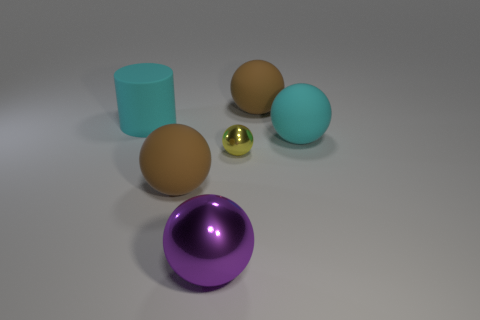Subtract all yellow balls. How many balls are left? 4 Subtract all large cyan matte spheres. How many spheres are left? 4 Subtract all cyan spheres. Subtract all yellow cylinders. How many spheres are left? 4 Add 3 big brown balls. How many objects exist? 9 Subtract 2 brown balls. How many objects are left? 4 Subtract all spheres. How many objects are left? 1 Subtract all large green shiny cubes. Subtract all small yellow balls. How many objects are left? 5 Add 4 large brown spheres. How many large brown spheres are left? 6 Add 3 tiny matte cubes. How many tiny matte cubes exist? 3 